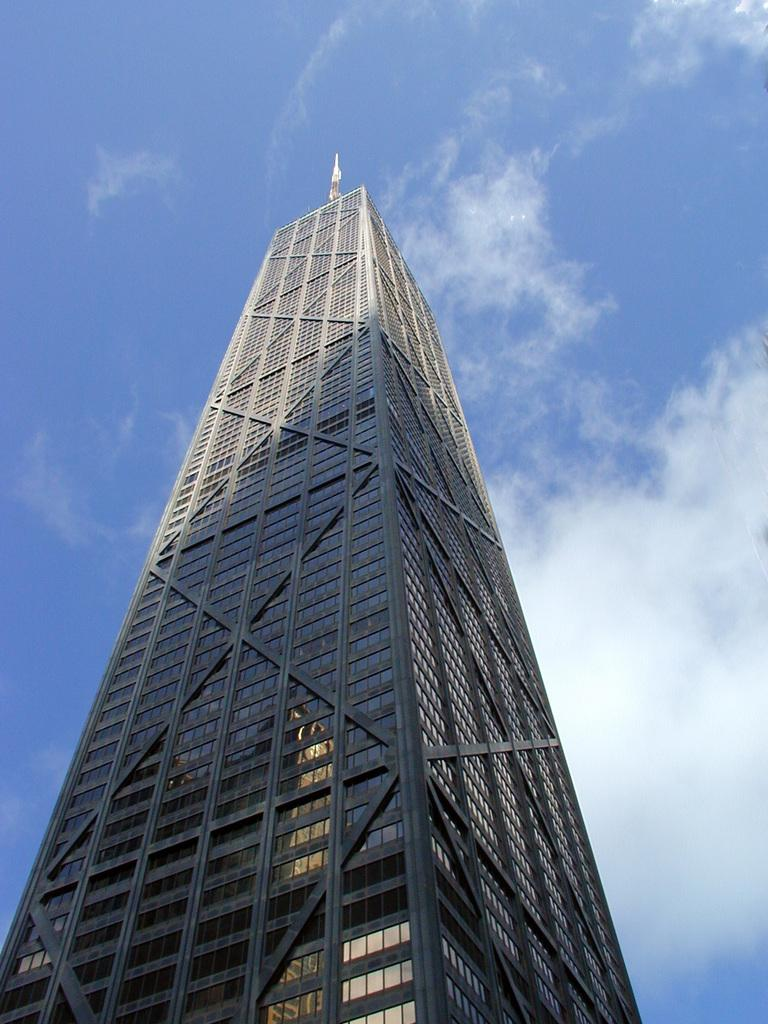What type of structure is present in the image? There is a building tower in the image. What can be seen in the sky in the image? Clouds are visible in the sky in the image. How many babies are standing on the feet of the machine in the image? There are no babies or machines present in the image. 